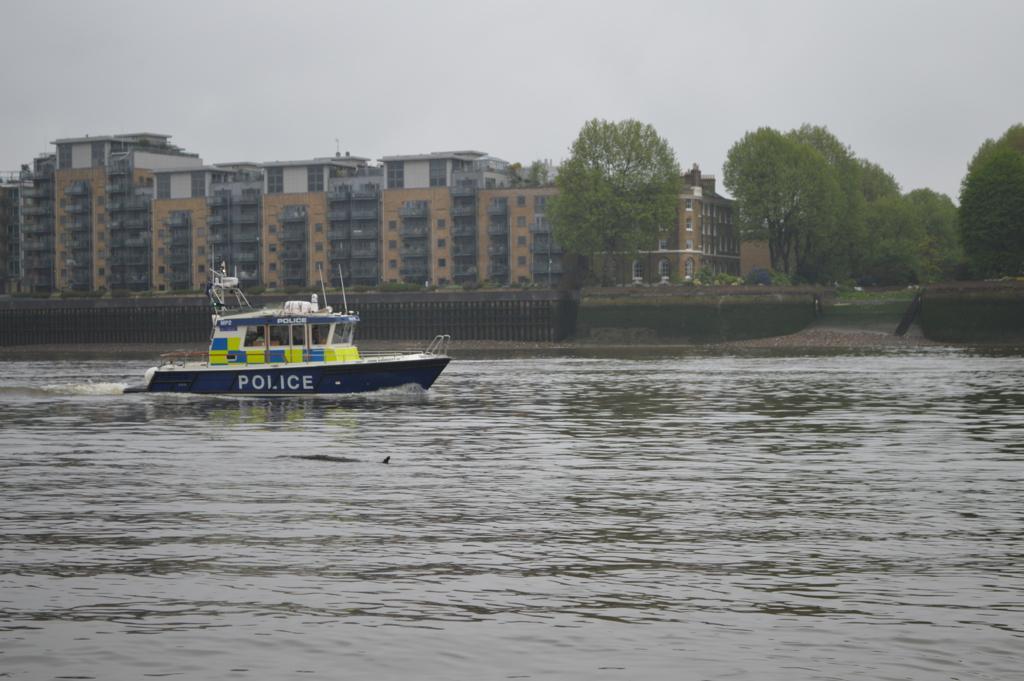Please provide a concise description of this image. In the foreground I can see a boat in the water. In the background I can see trees, fence, buildings and the sky. This image is taken may be near the lake. 